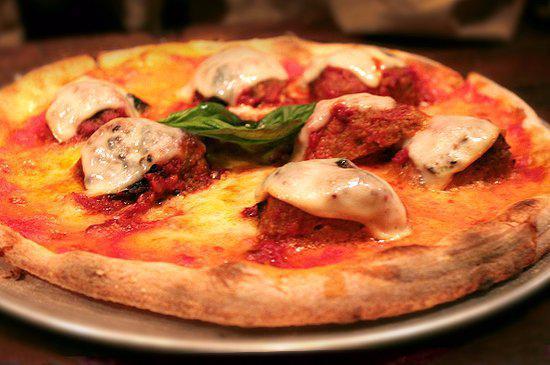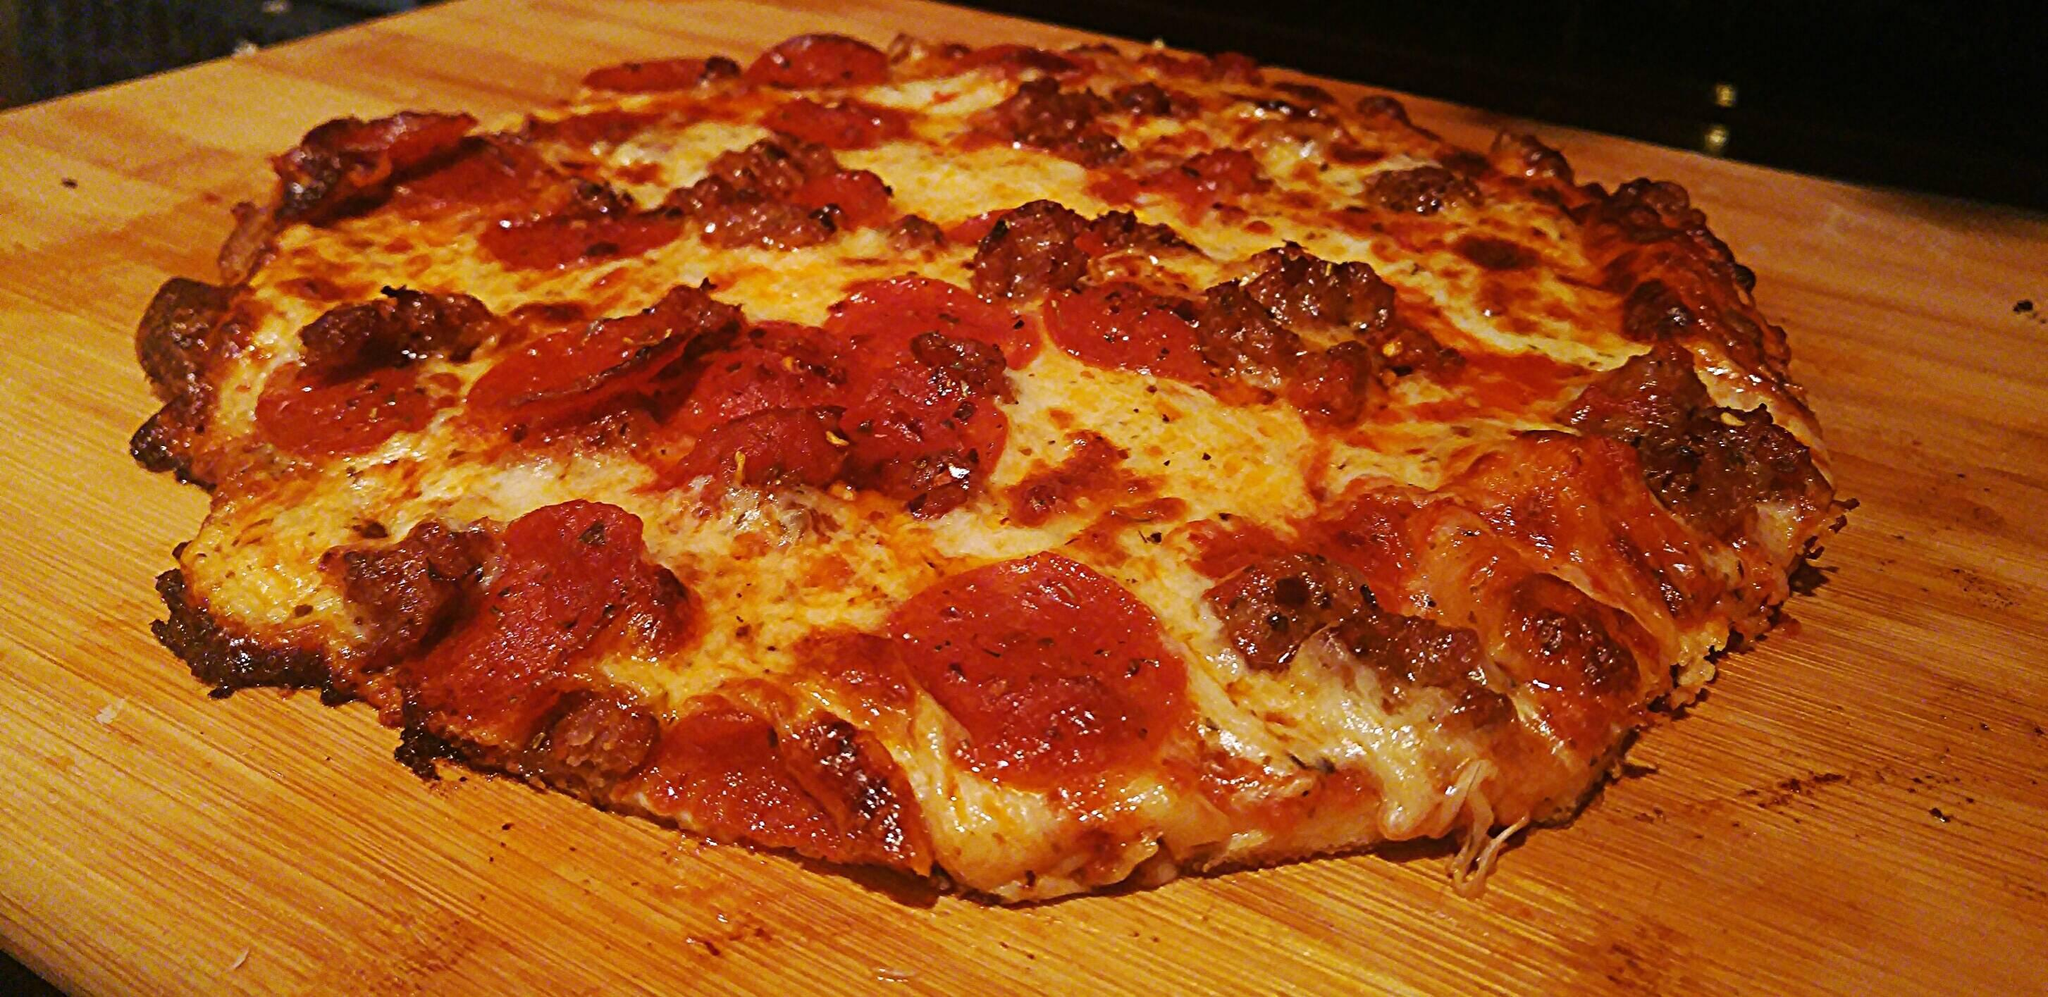The first image is the image on the left, the second image is the image on the right. Considering the images on both sides, is "There is a pizza cutter in the right image." valid? Answer yes or no. No. 